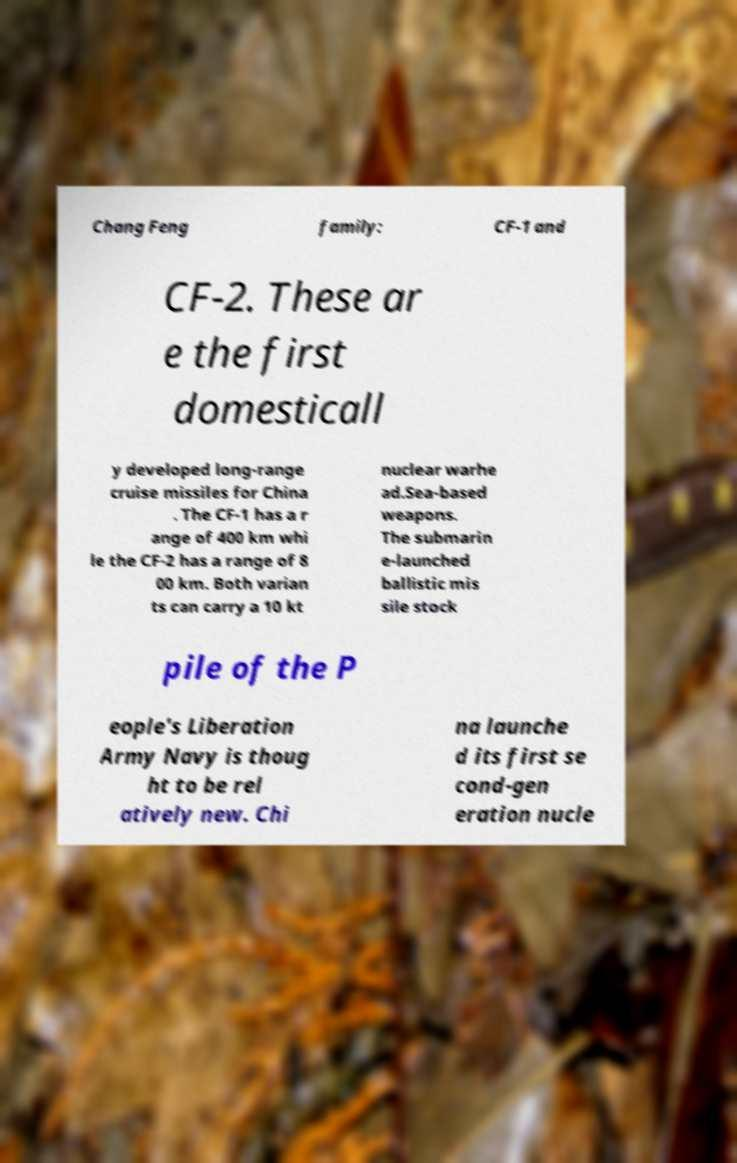I need the written content from this picture converted into text. Can you do that? Chang Feng family: CF-1 and CF-2. These ar e the first domesticall y developed long-range cruise missiles for China . The CF-1 has a r ange of 400 km whi le the CF-2 has a range of 8 00 km. Both varian ts can carry a 10 kt nuclear warhe ad.Sea-based weapons. The submarin e-launched ballistic mis sile stock pile of the P eople's Liberation Army Navy is thoug ht to be rel atively new. Chi na launche d its first se cond-gen eration nucle 